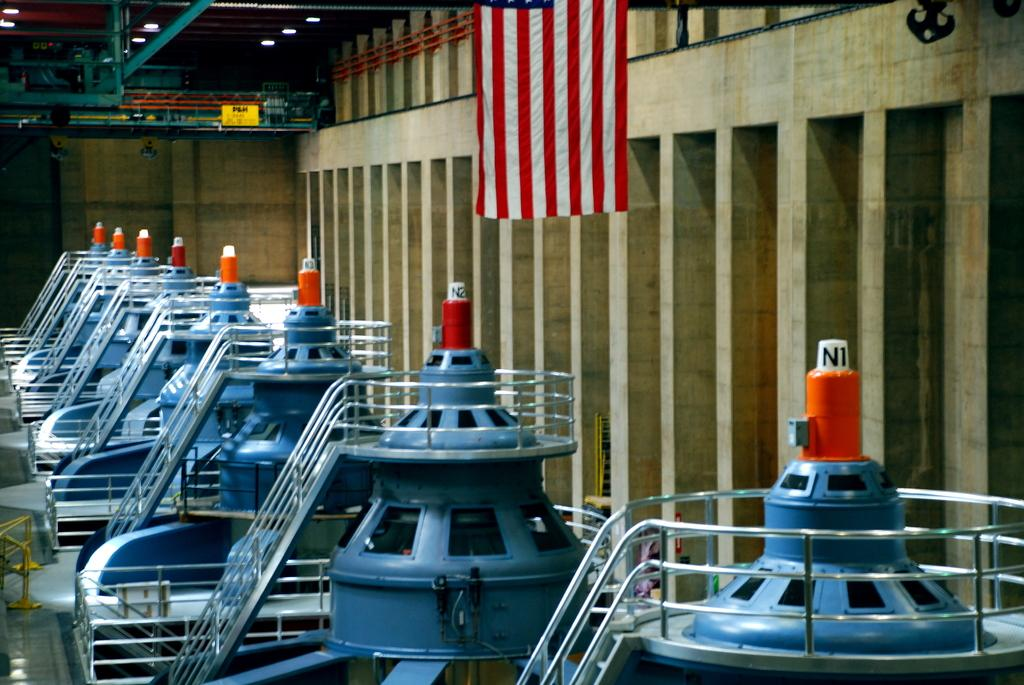What types of objects can be seen in the image? There are machines in the image. Is there any other notable feature in the image? Yes, there is a flag hanging at the top of the image. How many bushes can be seen in the image? There are no bushes present in the image. Is there a giraffe visible in the image? No, there is no giraffe present in the image. 